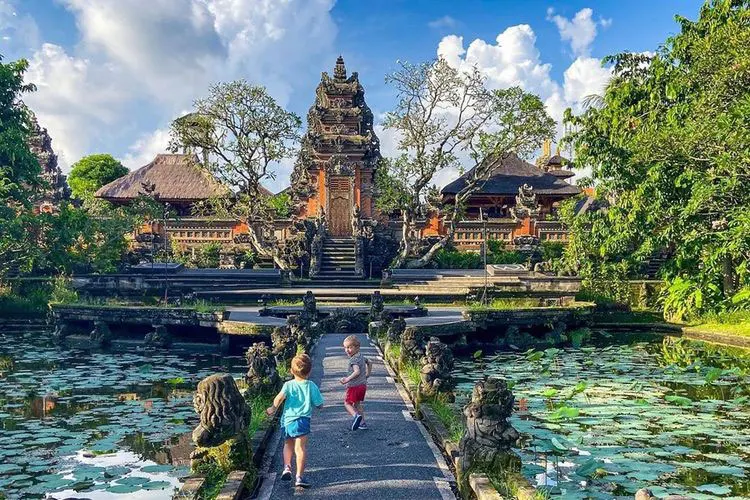Describe a realistic scenario of special cultural significance occurring here. A realistic scenario could be a traditional Balinese wedding ceremony taking place at the Ubud Water Palace. The bride and groom, dressed in elaborate ceremonial garments, would be surrounded by family and friends. The air would be filled with the scent of incense and flowers, while traditional Gamelan music would serenade the occasion. The ceremony would be rich in symbolic rituals, such as the exchange of floral garlands and offerings to deities, seeking blessings for a prosperous future. The palace, with its serene ambiance and cultural heritage, would provide a perfect backdrop, blending tradition and natural beauty.  Describe a short scenario of a family visit. A family visiting the Ubud Water Palace might start their day with a guided tour, learning about the history and cultural significance of the site. They would stroll through the lush gardens, taking in the tranquil beauty of the pond. The children might be fascinated by the statues and carvings, sparking their imagination. The family would enjoy a picnic in a shaded area, surrounded by the sounds of nature. The day would end with a peaceful walk along the pathways, creating cherished memories in this captivating setting. 